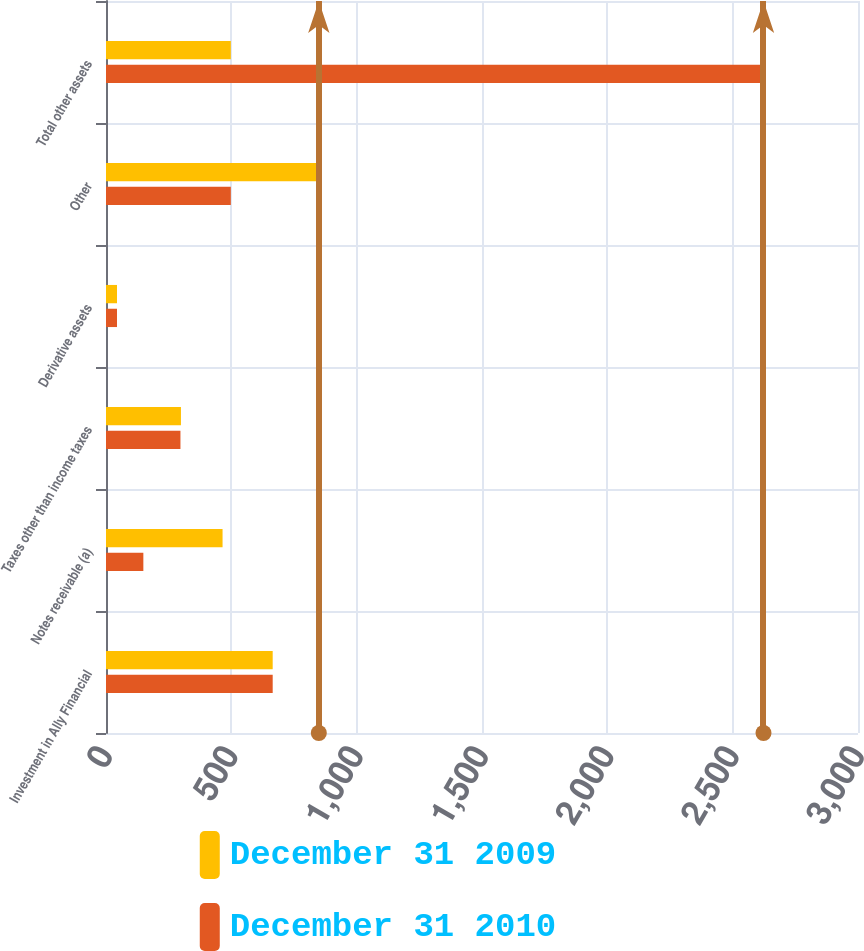Convert chart. <chart><loc_0><loc_0><loc_500><loc_500><stacked_bar_chart><ecel><fcel>Investment in Ally Financial<fcel>Notes receivable (a)<fcel>Taxes other than income taxes<fcel>Derivative assets<fcel>Other<fcel>Total other assets<nl><fcel>December 31 2009<fcel>665<fcel>465<fcel>299<fcel>44<fcel>849<fcel>498<nl><fcel>December 31 2010<fcel>665<fcel>149<fcel>297<fcel>44<fcel>498<fcel>2623<nl></chart> 